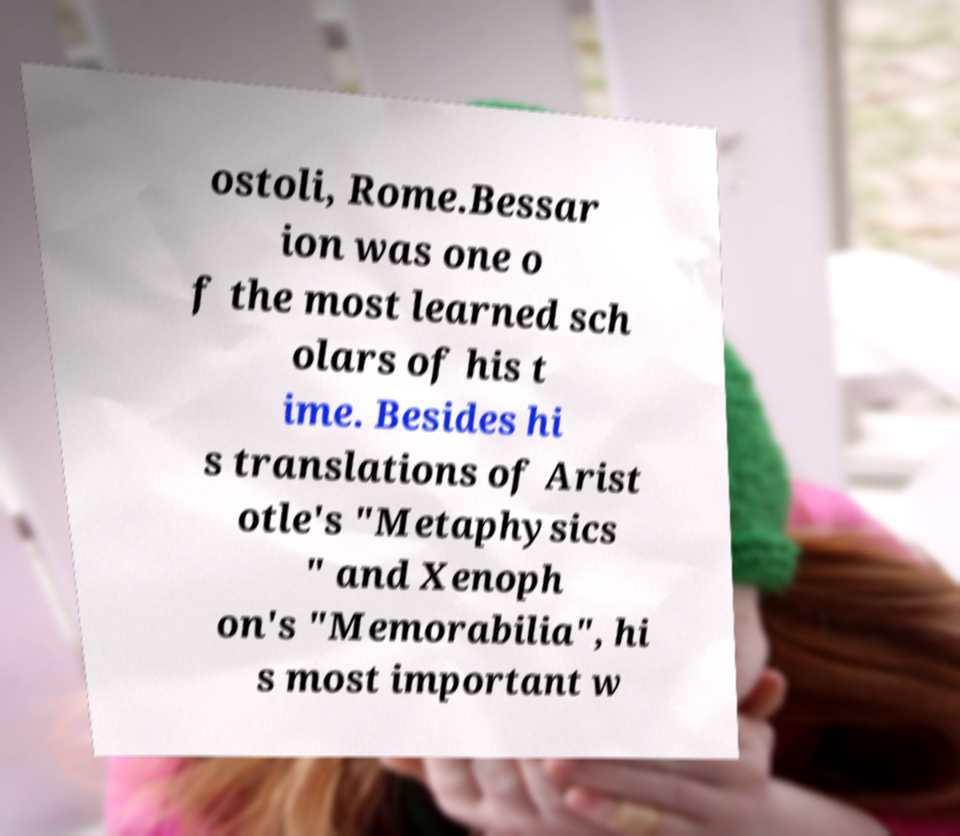For documentation purposes, I need the text within this image transcribed. Could you provide that? ostoli, Rome.Bessar ion was one o f the most learned sch olars of his t ime. Besides hi s translations of Arist otle's "Metaphysics " and Xenoph on's "Memorabilia", hi s most important w 